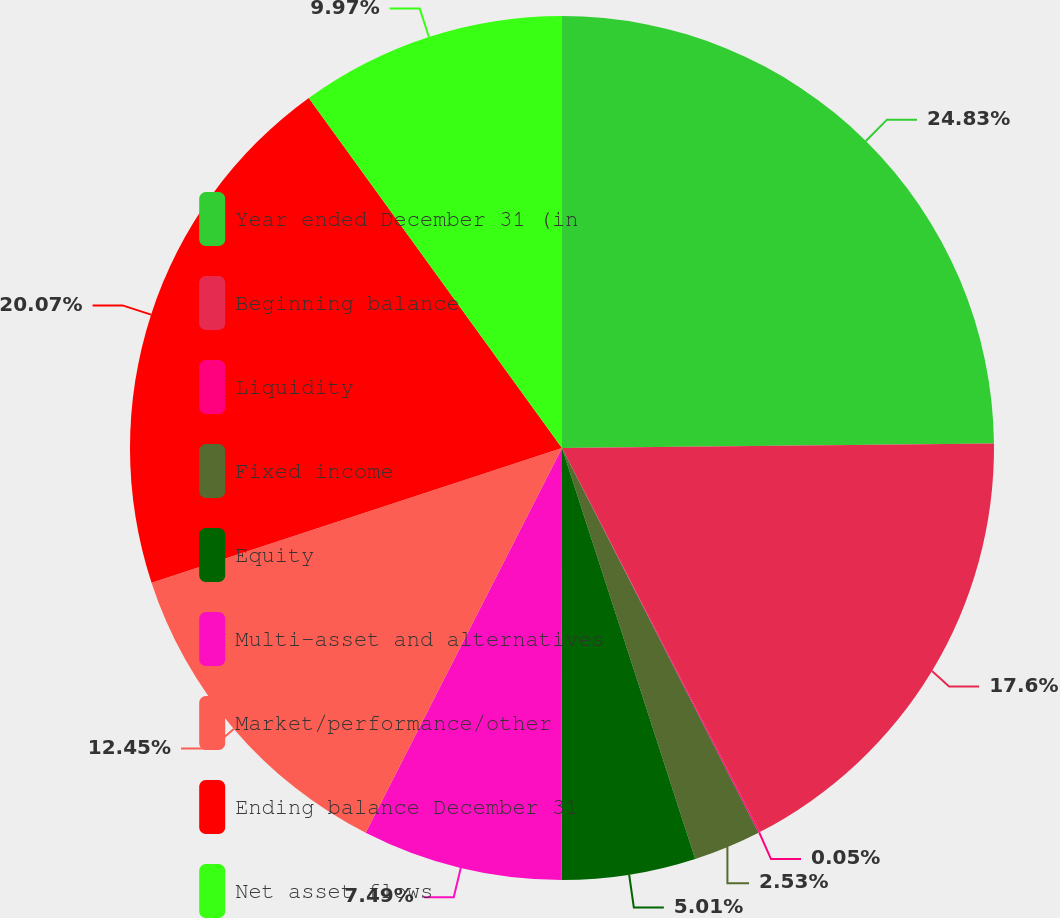<chart> <loc_0><loc_0><loc_500><loc_500><pie_chart><fcel>Year ended December 31 (in<fcel>Beginning balance<fcel>Liquidity<fcel>Fixed income<fcel>Equity<fcel>Multi-asset and alternatives<fcel>Market/performance/other<fcel>Ending balance December 31<fcel>Net asset flows<nl><fcel>24.84%<fcel>17.6%<fcel>0.05%<fcel>2.53%<fcel>5.01%<fcel>7.49%<fcel>12.45%<fcel>20.08%<fcel>9.97%<nl></chart> 